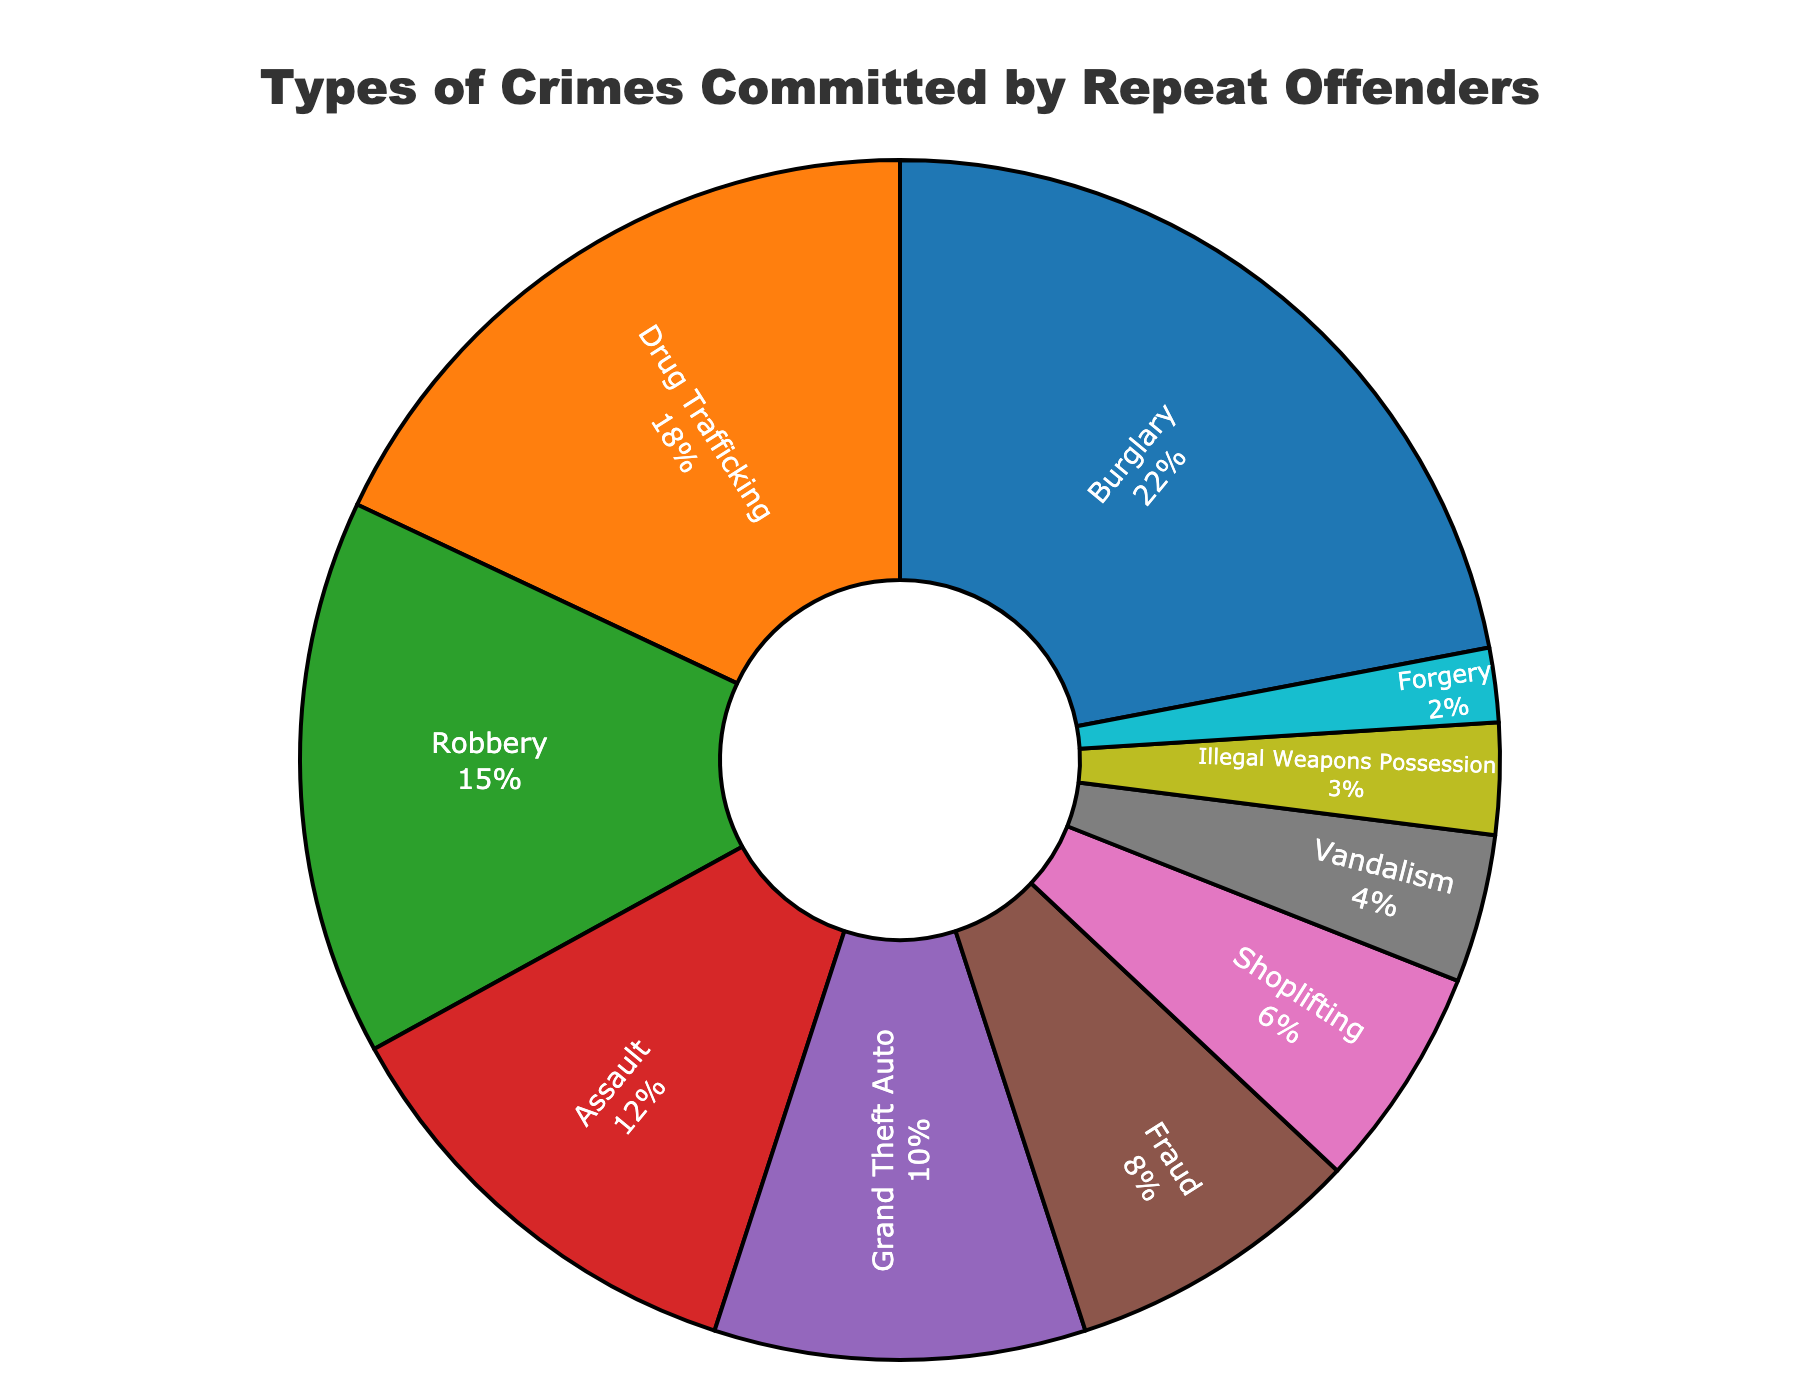Which type of crime is the most commonly committed by repeat offenders? The pie chart shows that Burglary has the largest segment among all types of crimes.
Answer: Burglary What is the percentage of crimes committed by repeat offenders that are classified as Robbery? Looking at the segment labeled "Robbery" on the pie chart, the percentage is indicated
Answer: 15% How much larger is the percentage of Burglary compared to Fraud? Burglary is 22% and Fraud is 8%. Subtracting the two percentages gives 22% - 8% = 14%.
Answer: 14% Are there more serious crimes (assault and above) or less serious ones (below assault) in terms of percentage? Summing the percentages for serious crimes (Burglary 22%, Drug Trafficking 18%, Robbery 15%, Assault 12%) gives 67%. Summing the percentages for less serious ones (Grand Theft Auto 10%, Fraud 8%, Shoplifting 6%, Vandalism 4%, Illegal Weapons Possession 3%, Forgery 2%) gives 33%.
Answer: More serious crimes Which has a larger percentage, Grand Theft Auto or Assault? The percentage for Grand Theft Auto is 10% and for Assault is 12%. Comparing the two, Assault has a larger percentage.
Answer: Assault What is the combined percentage of Drug Trafficking and Illegal Weapons Possession? Adding the percentages for Drug Trafficking (18%) and Illegal Weapons Possession (3%) gives 18% + 3% = 21%.
Answer: 21% How does the percentage of Shoplifting compare to that of Vandalism? The pie chart shows Shoplifting at 6% and Vandalism at 4%. Shoplifting has a higher percentage than Vandalism.
Answer: Shoplifting What is the sum of the percentages for Fraud, Shoplifting, and Forgery? Adding the percentages for Fraud (8%), Shoplifting (6%), and Forgery (2%) gives 8% + 6% + 2% = 16%.
Answer: 16% Compare the visual size of the sections for Drug Trafficking and Robbery. Which one is larger? The pie chart visually shows a larger segment for Drug Trafficking compared to Robbery.
Answer: Drug Trafficking 